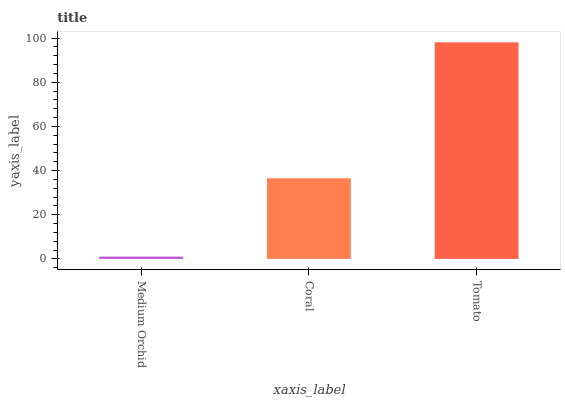Is Medium Orchid the minimum?
Answer yes or no. Yes. Is Tomato the maximum?
Answer yes or no. Yes. Is Coral the minimum?
Answer yes or no. No. Is Coral the maximum?
Answer yes or no. No. Is Coral greater than Medium Orchid?
Answer yes or no. Yes. Is Medium Orchid less than Coral?
Answer yes or no. Yes. Is Medium Orchid greater than Coral?
Answer yes or no. No. Is Coral less than Medium Orchid?
Answer yes or no. No. Is Coral the high median?
Answer yes or no. Yes. Is Coral the low median?
Answer yes or no. Yes. Is Medium Orchid the high median?
Answer yes or no. No. Is Tomato the low median?
Answer yes or no. No. 